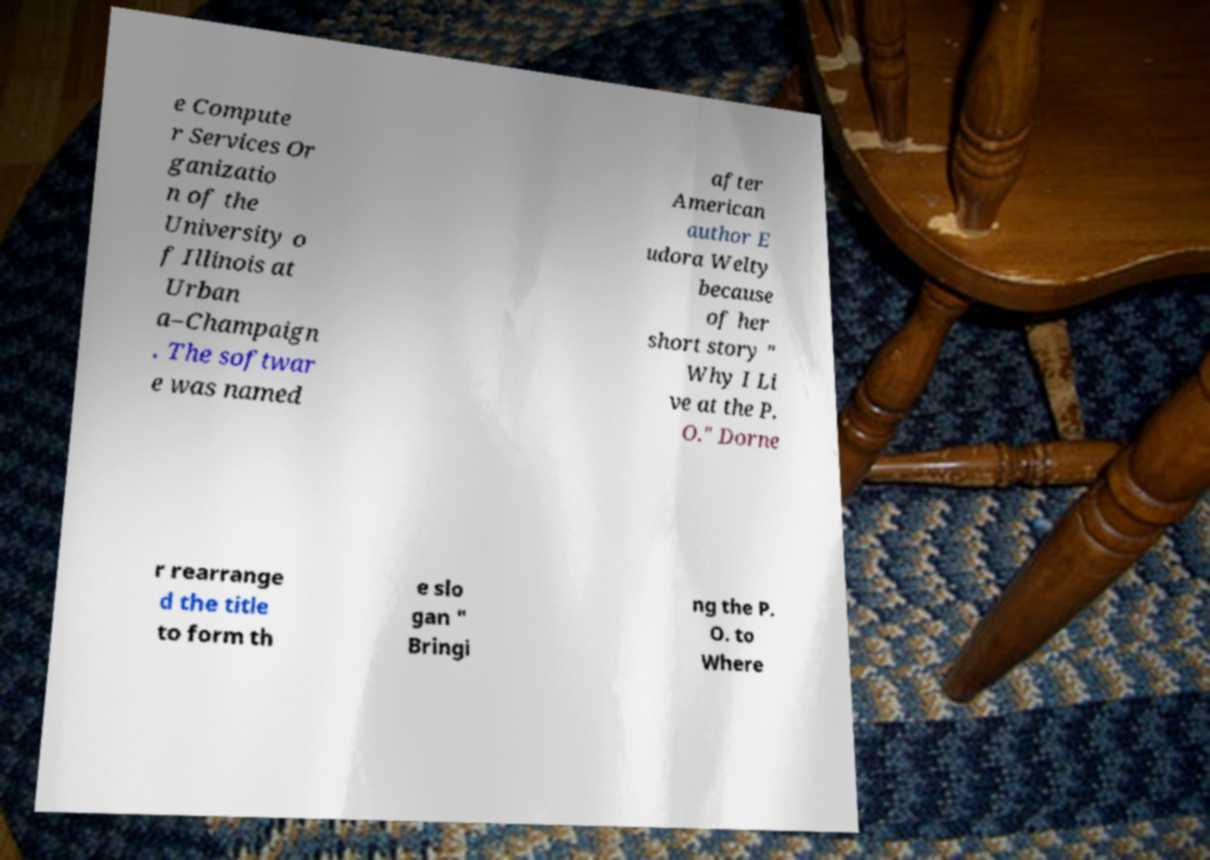For documentation purposes, I need the text within this image transcribed. Could you provide that? e Compute r Services Or ganizatio n of the University o f Illinois at Urban a–Champaign . The softwar e was named after American author E udora Welty because of her short story " Why I Li ve at the P. O." Dorne r rearrange d the title to form th e slo gan " Bringi ng the P. O. to Where 